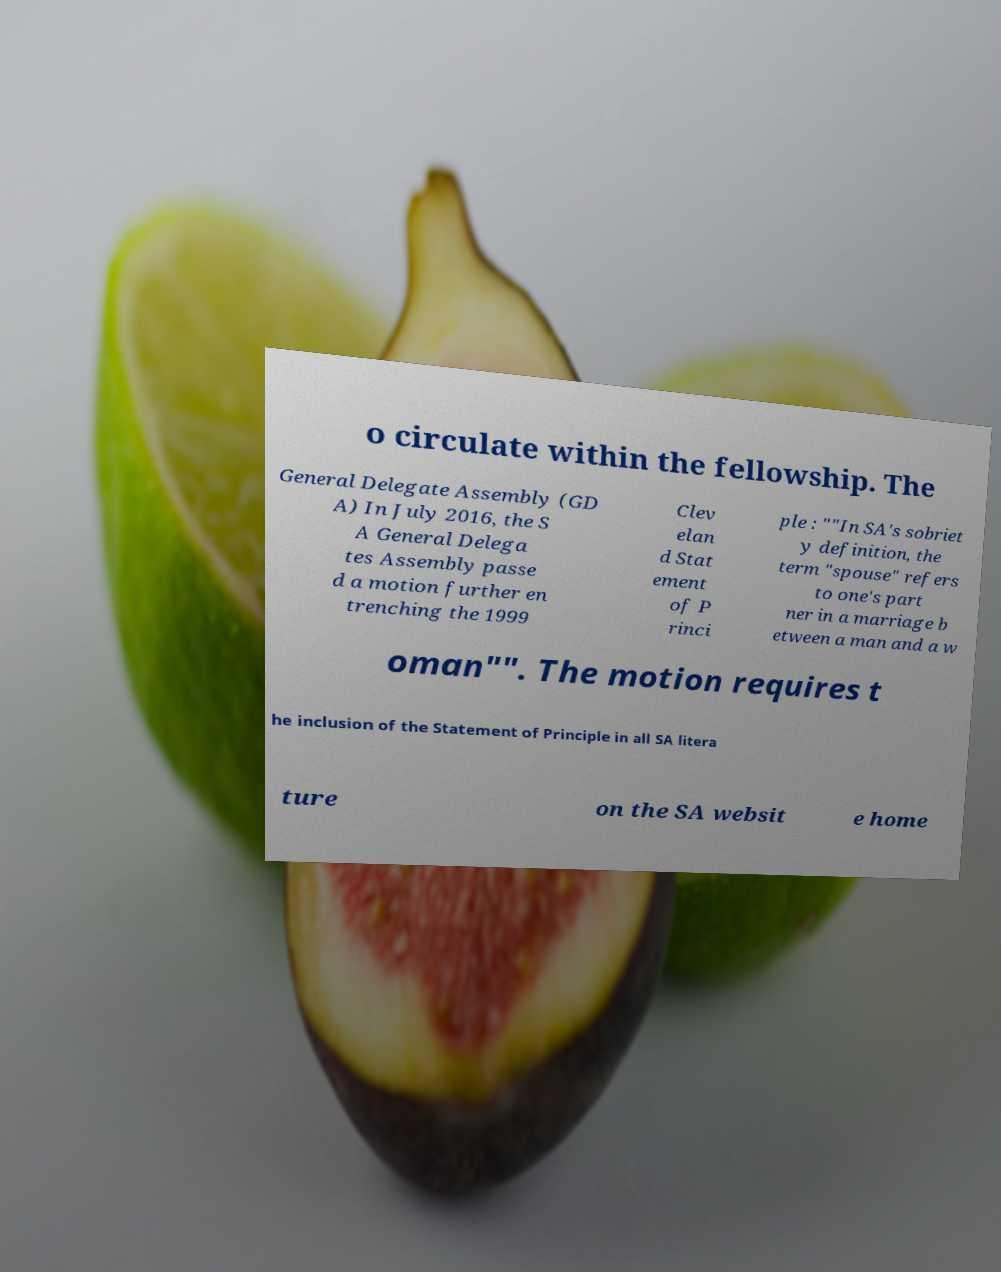I need the written content from this picture converted into text. Can you do that? o circulate within the fellowship. The General Delegate Assembly (GD A) In July 2016, the S A General Delega tes Assembly passe d a motion further en trenching the 1999 Clev elan d Stat ement of P rinci ple : ""In SA's sobriet y definition, the term "spouse" refers to one's part ner in a marriage b etween a man and a w oman"". The motion requires t he inclusion of the Statement of Principle in all SA litera ture on the SA websit e home 